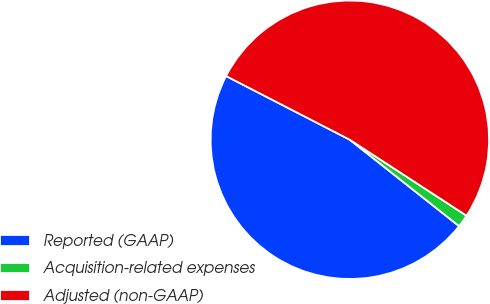Convert chart. <chart><loc_0><loc_0><loc_500><loc_500><pie_chart><fcel>Reported (GAAP)<fcel>Acquisition-related expenses<fcel>Adjusted (non-GAAP)<nl><fcel>46.92%<fcel>1.47%<fcel>51.61%<nl></chart> 